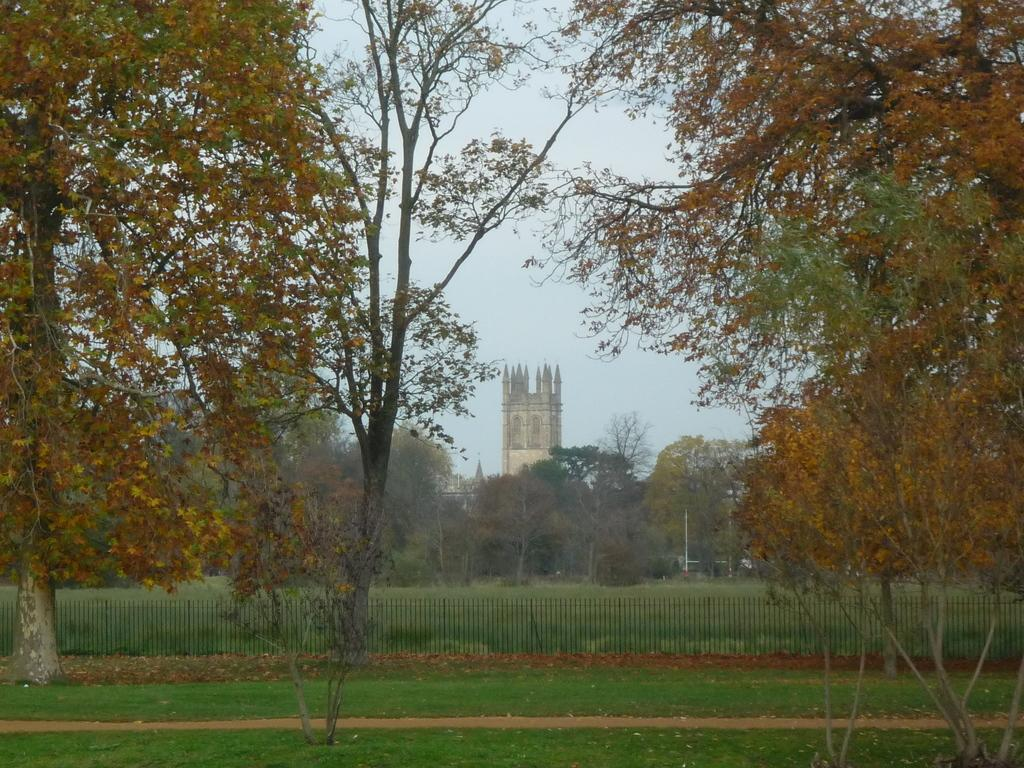What type of vegetation is present on the ground in the image? There is grass on the ground in the image. What structure can be seen in the image? There is a fence in the image. What other natural elements are visible in the image? There are trees in the image. Can you describe the building that is visible in the image? There is a building visible between the trees in the image. What type of jewel is being worn by the plant in the image? There is no plant or jewel present in the image. What achievement has the achiever accomplished in the image? There is no achiever or achievement present in the image. 